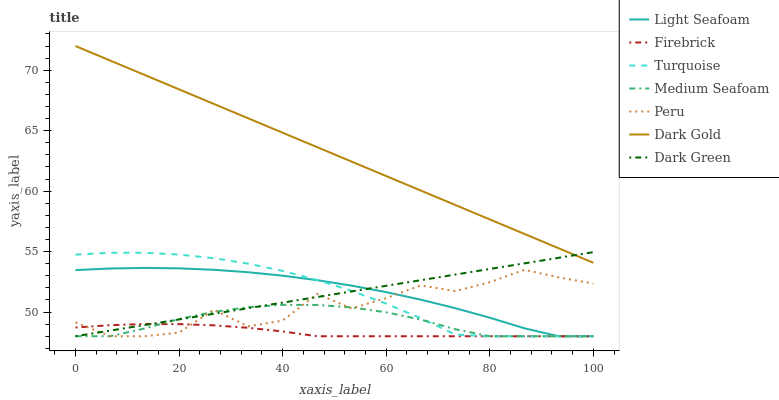Does Firebrick have the minimum area under the curve?
Answer yes or no. Yes. Does Dark Gold have the maximum area under the curve?
Answer yes or no. Yes. Does Dark Gold have the minimum area under the curve?
Answer yes or no. No. Does Firebrick have the maximum area under the curve?
Answer yes or no. No. Is Dark Gold the smoothest?
Answer yes or no. Yes. Is Peru the roughest?
Answer yes or no. Yes. Is Firebrick the smoothest?
Answer yes or no. No. Is Firebrick the roughest?
Answer yes or no. No. Does Dark Gold have the lowest value?
Answer yes or no. No. Does Dark Gold have the highest value?
Answer yes or no. Yes. Does Firebrick have the highest value?
Answer yes or no. No. Is Turquoise less than Dark Gold?
Answer yes or no. Yes. Is Dark Gold greater than Peru?
Answer yes or no. Yes. Does Dark Green intersect Peru?
Answer yes or no. Yes. Is Dark Green less than Peru?
Answer yes or no. No. Is Dark Green greater than Peru?
Answer yes or no. No. Does Turquoise intersect Dark Gold?
Answer yes or no. No. 